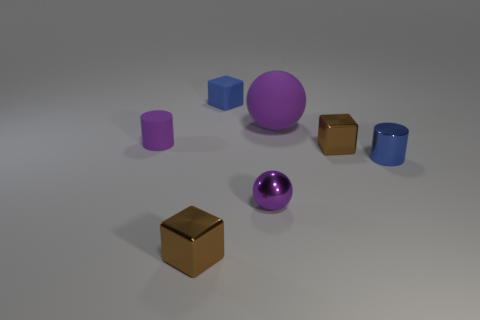The tiny purple rubber object is what shape?
Your answer should be compact. Cylinder. What is the size of the matte sphere that is the same color as the metallic ball?
Offer a terse response. Large. What is the material of the tiny blue cylinder?
Your answer should be compact. Metal. The shiny object that is the same color as the tiny rubber cube is what shape?
Provide a short and direct response. Cylinder. What number of brown rubber blocks have the same size as the purple metallic object?
Provide a succinct answer. 0. What number of things are blue things in front of the small purple rubber object or tiny shiny objects on the left side of the tiny blue cylinder?
Provide a short and direct response. 4. Are the blue thing that is on the left side of the small purple metal ball and the tiny brown cube that is behind the tiny blue shiny cylinder made of the same material?
Ensure brevity in your answer.  No. What is the shape of the tiny purple object right of the rubber object that is behind the large rubber ball?
Offer a very short reply. Sphere. Is there a big purple matte ball that is behind the small cylinder on the left side of the object behind the rubber ball?
Ensure brevity in your answer.  Yes. Does the cylinder left of the blue matte object have the same color as the sphere that is left of the big purple rubber sphere?
Your answer should be very brief. Yes. 